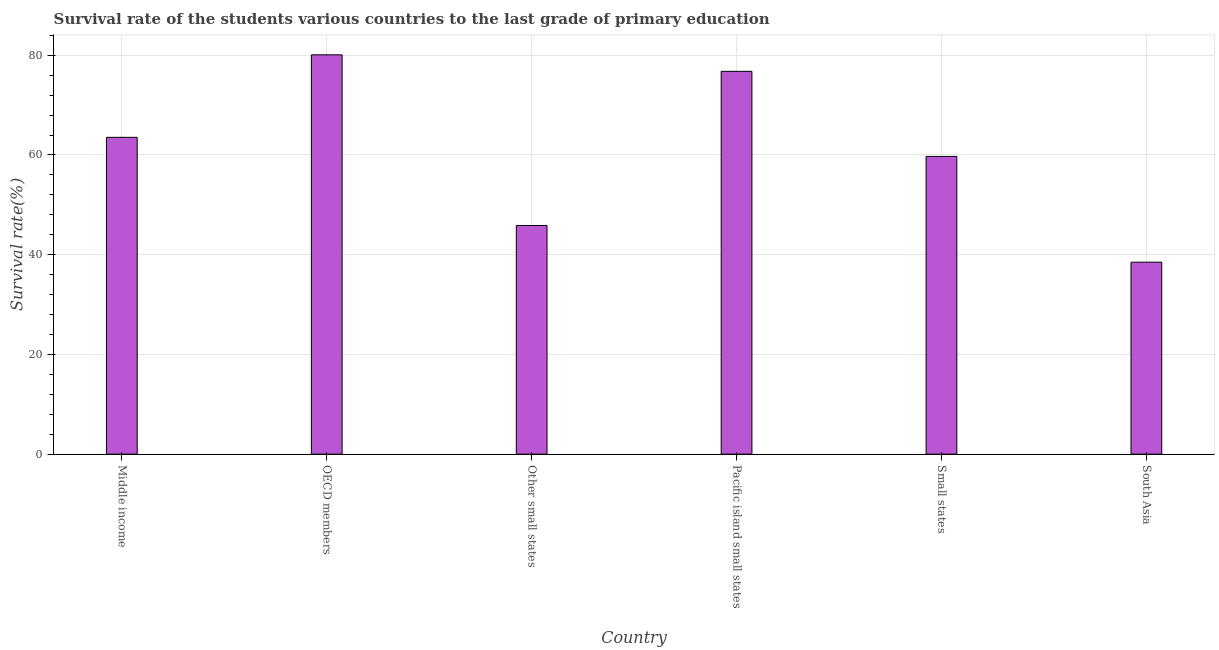Does the graph contain any zero values?
Your response must be concise. No. What is the title of the graph?
Keep it short and to the point. Survival rate of the students various countries to the last grade of primary education. What is the label or title of the X-axis?
Offer a very short reply. Country. What is the label or title of the Y-axis?
Keep it short and to the point. Survival rate(%). What is the survival rate in primary education in OECD members?
Provide a succinct answer. 80.08. Across all countries, what is the maximum survival rate in primary education?
Provide a succinct answer. 80.08. Across all countries, what is the minimum survival rate in primary education?
Keep it short and to the point. 38.5. In which country was the survival rate in primary education maximum?
Keep it short and to the point. OECD members. In which country was the survival rate in primary education minimum?
Your response must be concise. South Asia. What is the sum of the survival rate in primary education?
Your response must be concise. 364.44. What is the difference between the survival rate in primary education in Pacific island small states and Small states?
Provide a succinct answer. 17.06. What is the average survival rate in primary education per country?
Offer a terse response. 60.74. What is the median survival rate in primary education?
Offer a very short reply. 61.62. In how many countries, is the survival rate in primary education greater than 8 %?
Your response must be concise. 6. What is the ratio of the survival rate in primary education in Other small states to that in South Asia?
Keep it short and to the point. 1.19. Is the survival rate in primary education in Middle income less than that in Small states?
Provide a short and direct response. No. What is the difference between the highest and the second highest survival rate in primary education?
Make the answer very short. 3.31. Is the sum of the survival rate in primary education in Pacific island small states and Small states greater than the maximum survival rate in primary education across all countries?
Give a very brief answer. Yes. What is the difference between the highest and the lowest survival rate in primary education?
Offer a terse response. 41.58. Are the values on the major ticks of Y-axis written in scientific E-notation?
Provide a succinct answer. No. What is the Survival rate(%) of Middle income?
Your response must be concise. 63.53. What is the Survival rate(%) in OECD members?
Offer a terse response. 80.08. What is the Survival rate(%) in Other small states?
Keep it short and to the point. 45.86. What is the Survival rate(%) of Pacific island small states?
Your answer should be compact. 76.77. What is the Survival rate(%) in Small states?
Offer a terse response. 59.71. What is the Survival rate(%) of South Asia?
Offer a very short reply. 38.5. What is the difference between the Survival rate(%) in Middle income and OECD members?
Provide a succinct answer. -16.54. What is the difference between the Survival rate(%) in Middle income and Other small states?
Offer a terse response. 17.68. What is the difference between the Survival rate(%) in Middle income and Pacific island small states?
Provide a short and direct response. -13.23. What is the difference between the Survival rate(%) in Middle income and Small states?
Make the answer very short. 3.83. What is the difference between the Survival rate(%) in Middle income and South Asia?
Offer a very short reply. 25.04. What is the difference between the Survival rate(%) in OECD members and Other small states?
Offer a terse response. 34.22. What is the difference between the Survival rate(%) in OECD members and Pacific island small states?
Ensure brevity in your answer.  3.31. What is the difference between the Survival rate(%) in OECD members and Small states?
Keep it short and to the point. 20.37. What is the difference between the Survival rate(%) in OECD members and South Asia?
Your answer should be compact. 41.58. What is the difference between the Survival rate(%) in Other small states and Pacific island small states?
Your response must be concise. -30.91. What is the difference between the Survival rate(%) in Other small states and Small states?
Provide a succinct answer. -13.85. What is the difference between the Survival rate(%) in Other small states and South Asia?
Provide a succinct answer. 7.36. What is the difference between the Survival rate(%) in Pacific island small states and Small states?
Provide a short and direct response. 17.06. What is the difference between the Survival rate(%) in Pacific island small states and South Asia?
Give a very brief answer. 38.27. What is the difference between the Survival rate(%) in Small states and South Asia?
Your answer should be very brief. 21.21. What is the ratio of the Survival rate(%) in Middle income to that in OECD members?
Provide a short and direct response. 0.79. What is the ratio of the Survival rate(%) in Middle income to that in Other small states?
Give a very brief answer. 1.39. What is the ratio of the Survival rate(%) in Middle income to that in Pacific island small states?
Your response must be concise. 0.83. What is the ratio of the Survival rate(%) in Middle income to that in Small states?
Provide a short and direct response. 1.06. What is the ratio of the Survival rate(%) in Middle income to that in South Asia?
Provide a succinct answer. 1.65. What is the ratio of the Survival rate(%) in OECD members to that in Other small states?
Offer a very short reply. 1.75. What is the ratio of the Survival rate(%) in OECD members to that in Pacific island small states?
Give a very brief answer. 1.04. What is the ratio of the Survival rate(%) in OECD members to that in Small states?
Ensure brevity in your answer.  1.34. What is the ratio of the Survival rate(%) in OECD members to that in South Asia?
Give a very brief answer. 2.08. What is the ratio of the Survival rate(%) in Other small states to that in Pacific island small states?
Provide a short and direct response. 0.6. What is the ratio of the Survival rate(%) in Other small states to that in Small states?
Ensure brevity in your answer.  0.77. What is the ratio of the Survival rate(%) in Other small states to that in South Asia?
Make the answer very short. 1.19. What is the ratio of the Survival rate(%) in Pacific island small states to that in Small states?
Make the answer very short. 1.29. What is the ratio of the Survival rate(%) in Pacific island small states to that in South Asia?
Give a very brief answer. 1.99. What is the ratio of the Survival rate(%) in Small states to that in South Asia?
Your response must be concise. 1.55. 